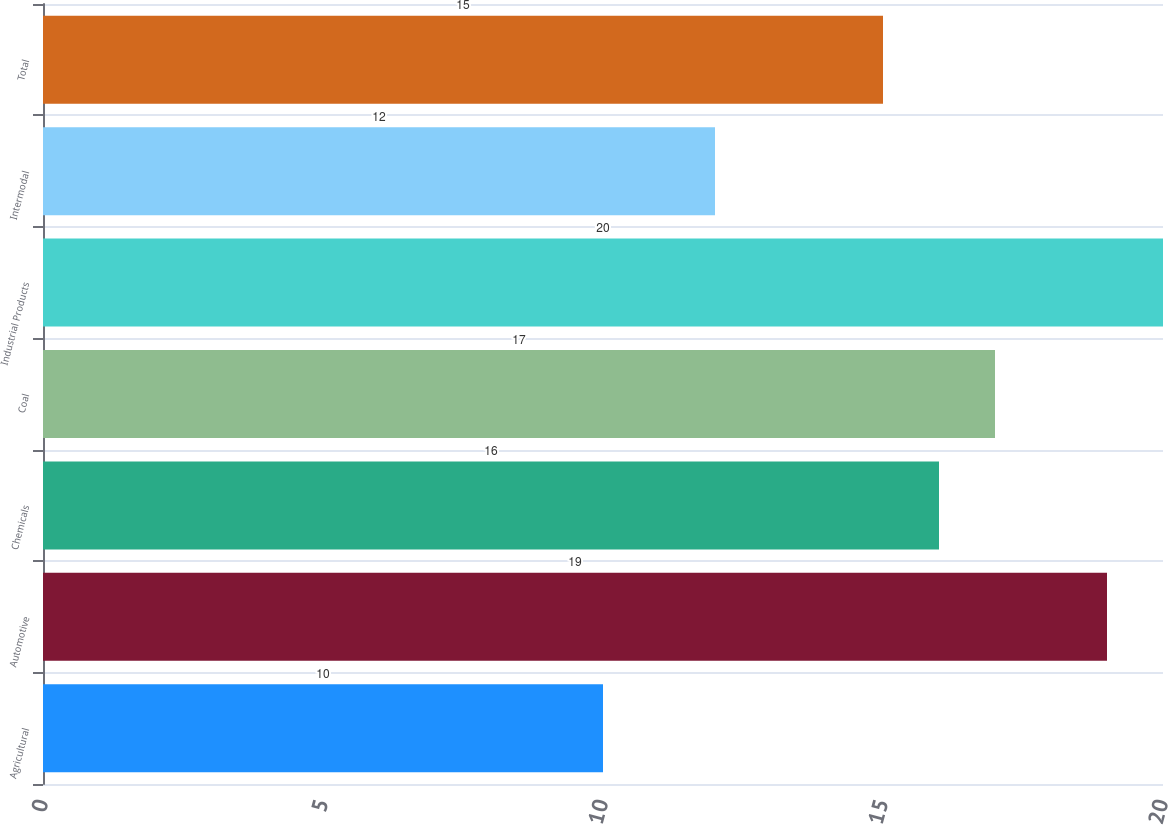Convert chart. <chart><loc_0><loc_0><loc_500><loc_500><bar_chart><fcel>Agricultural<fcel>Automotive<fcel>Chemicals<fcel>Coal<fcel>Industrial Products<fcel>Intermodal<fcel>Total<nl><fcel>10<fcel>19<fcel>16<fcel>17<fcel>20<fcel>12<fcel>15<nl></chart> 